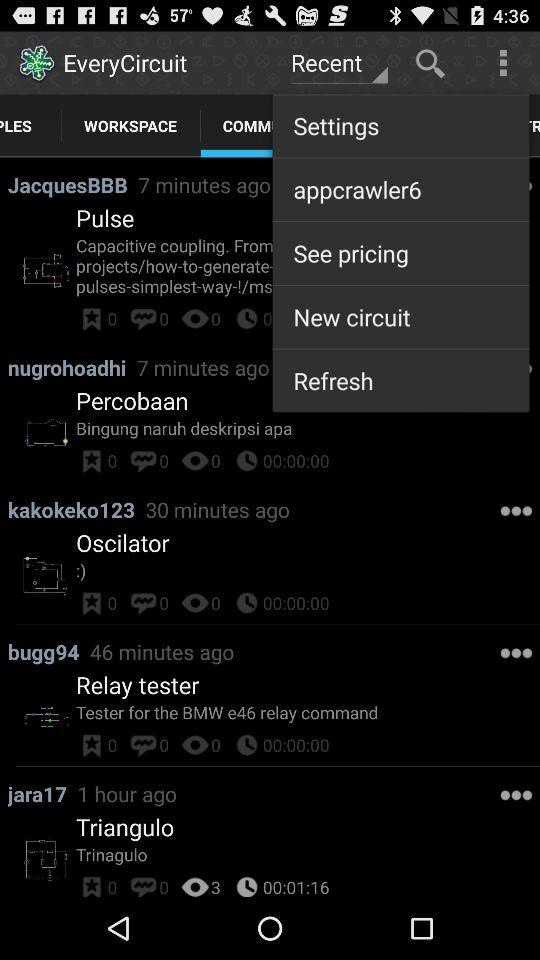How many views are there of "Triangulo"? There are 3 views of "Triangulo". 